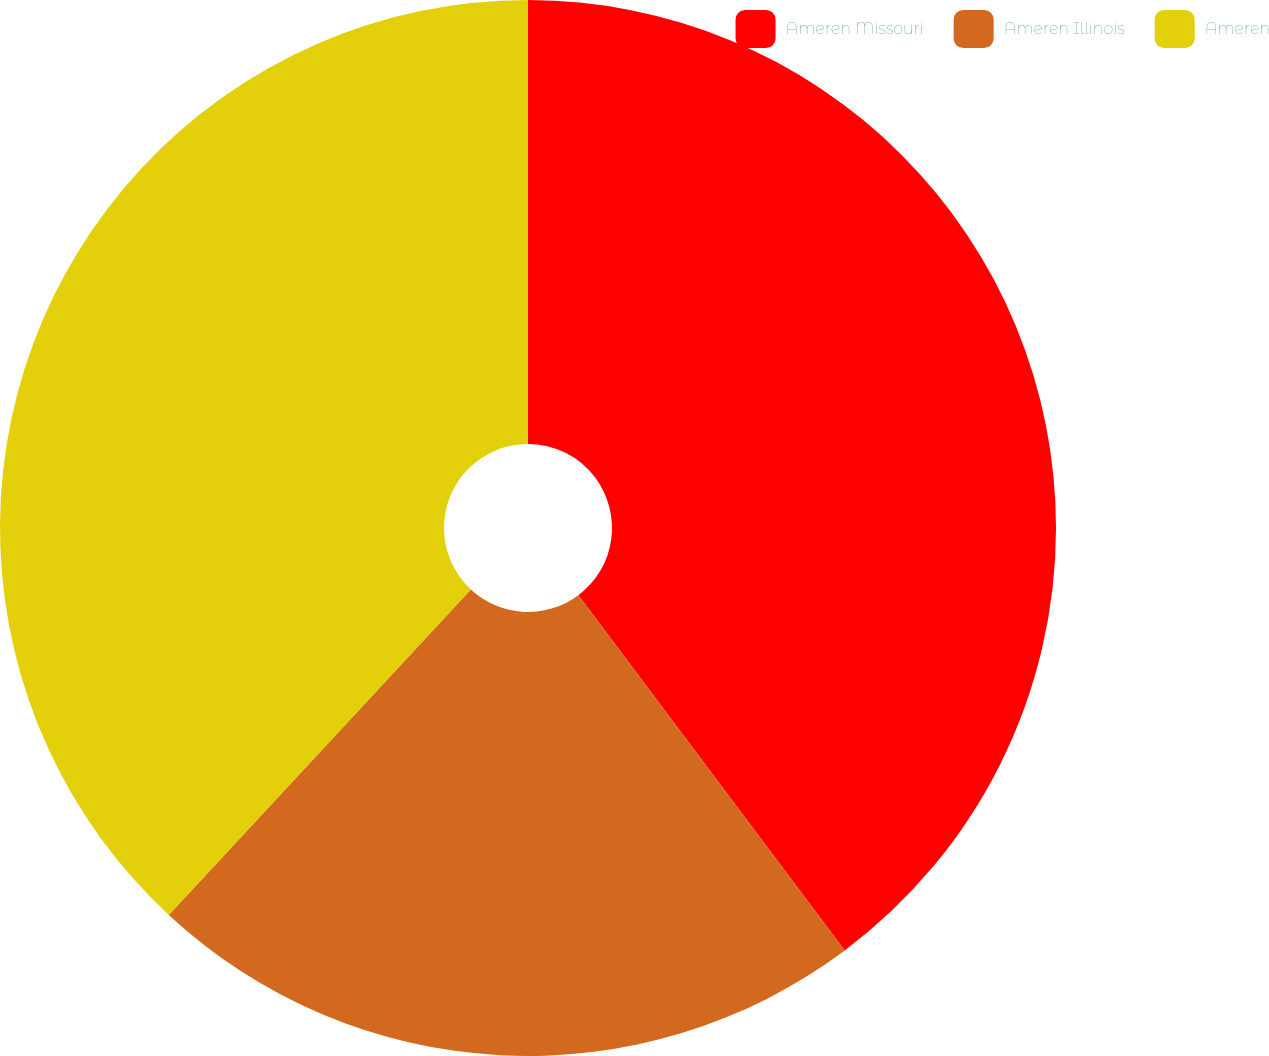<chart> <loc_0><loc_0><loc_500><loc_500><pie_chart><fcel>Ameren Missouri<fcel>Ameren Illinois<fcel>Ameren<nl><fcel>39.76%<fcel>22.15%<fcel>38.09%<nl></chart> 